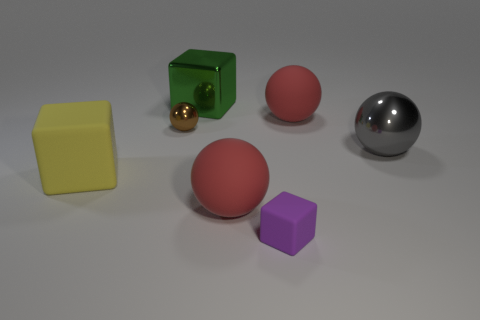How many large objects are behind the brown sphere and on the right side of the purple rubber block?
Your answer should be very brief. 1. Is there anything else that is the same color as the small cube?
Your response must be concise. No. There is a big object that is the same material as the gray sphere; what is its shape?
Ensure brevity in your answer.  Cube. Does the gray sphere have the same size as the green shiny object?
Offer a very short reply. Yes. Is the material of the tiny thing behind the tiny cube the same as the big gray object?
Your answer should be very brief. Yes. Is there anything else that has the same material as the big green object?
Give a very brief answer. Yes. There is a red rubber sphere that is in front of the red rubber object behind the tiny metallic sphere; what number of big matte spheres are right of it?
Provide a succinct answer. 1. There is a big red thing left of the tiny rubber cube; is it the same shape as the big gray object?
Keep it short and to the point. Yes. How many things are either green cylinders or red matte balls to the right of the tiny purple matte thing?
Provide a short and direct response. 1. Is the number of big yellow rubber blocks that are behind the brown ball greater than the number of tiny cubes?
Keep it short and to the point. No. 